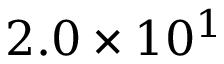<formula> <loc_0><loc_0><loc_500><loc_500>2 . 0 \times 1 0 ^ { 1 }</formula> 